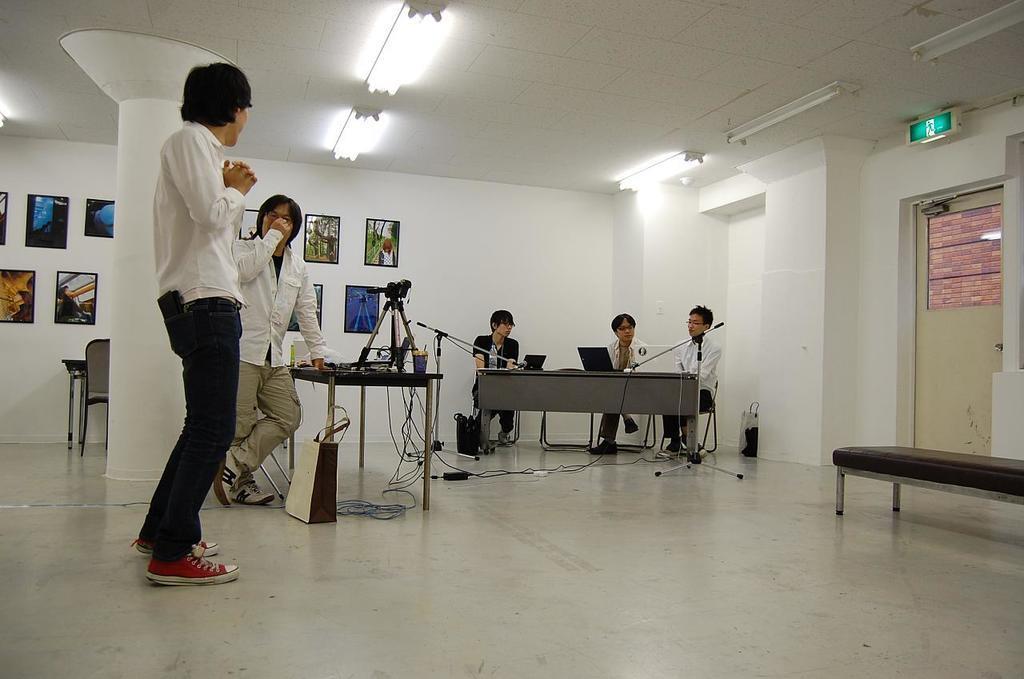Can you describe this image briefly? In this image there are some people some of them are standing and some of them are sitting and also there are some tables. On the table there are some laptops, wires and some other objects. At the bottom there is a floor, on the floor there is one bench. On the right side and in the background there are some photo frames on the wall, and on the right side there is a door and a board. On the top there is ceiling and some lights. 